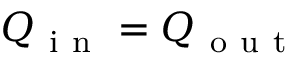<formula> <loc_0><loc_0><loc_500><loc_500>Q _ { i n } = Q _ { o u t }</formula> 